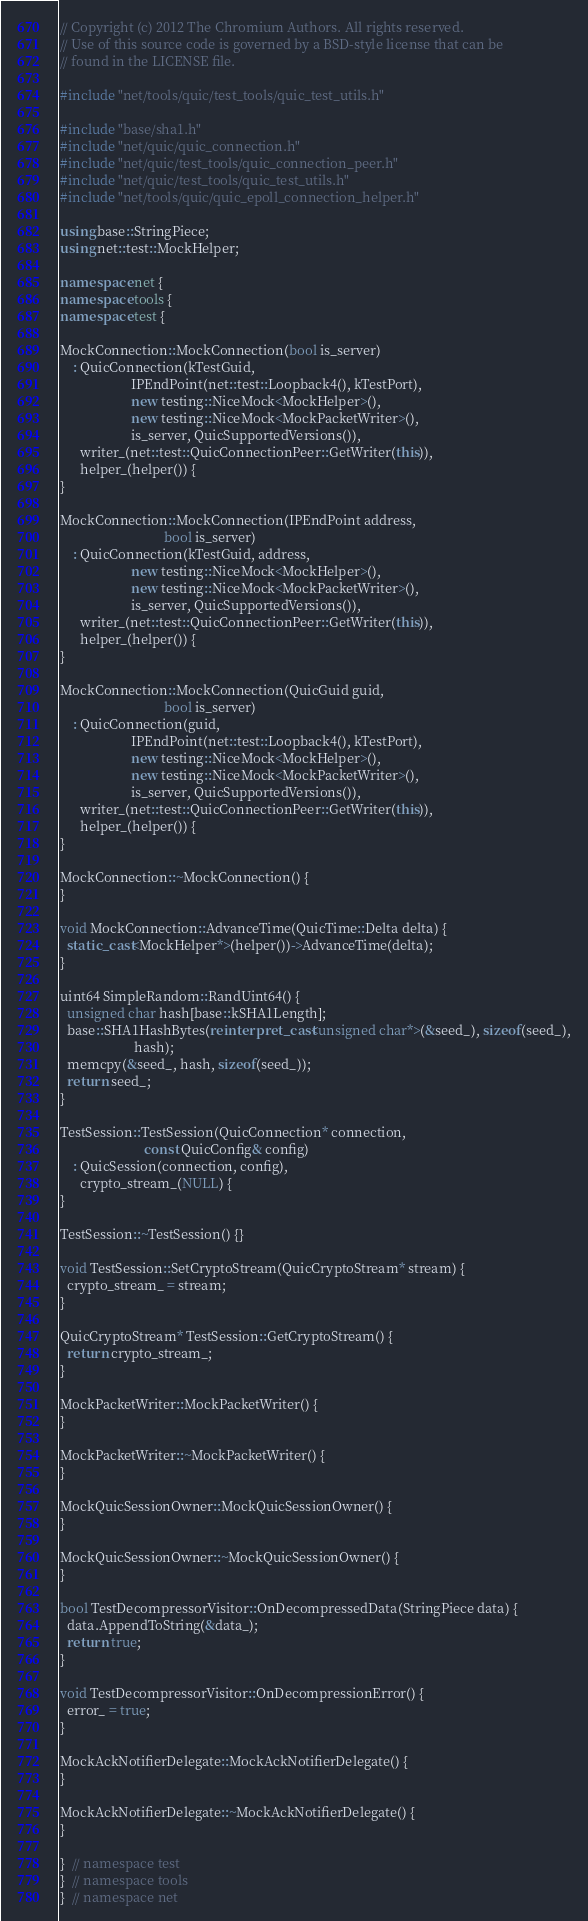<code> <loc_0><loc_0><loc_500><loc_500><_C++_>// Copyright (c) 2012 The Chromium Authors. All rights reserved.
// Use of this source code is governed by a BSD-style license that can be
// found in the LICENSE file.

#include "net/tools/quic/test_tools/quic_test_utils.h"

#include "base/sha1.h"
#include "net/quic/quic_connection.h"
#include "net/quic/test_tools/quic_connection_peer.h"
#include "net/quic/test_tools/quic_test_utils.h"
#include "net/tools/quic/quic_epoll_connection_helper.h"

using base::StringPiece;
using net::test::MockHelper;

namespace net {
namespace tools {
namespace test {

MockConnection::MockConnection(bool is_server)
    : QuicConnection(kTestGuid,
                     IPEndPoint(net::test::Loopback4(), kTestPort),
                     new testing::NiceMock<MockHelper>(),
                     new testing::NiceMock<MockPacketWriter>(),
                     is_server, QuicSupportedVersions()),
      writer_(net::test::QuicConnectionPeer::GetWriter(this)),
      helper_(helper()) {
}

MockConnection::MockConnection(IPEndPoint address,
                               bool is_server)
    : QuicConnection(kTestGuid, address,
                     new testing::NiceMock<MockHelper>(),
                     new testing::NiceMock<MockPacketWriter>(),
                     is_server, QuicSupportedVersions()),
      writer_(net::test::QuicConnectionPeer::GetWriter(this)),
      helper_(helper()) {
}

MockConnection::MockConnection(QuicGuid guid,
                               bool is_server)
    : QuicConnection(guid,
                     IPEndPoint(net::test::Loopback4(), kTestPort),
                     new testing::NiceMock<MockHelper>(),
                     new testing::NiceMock<MockPacketWriter>(),
                     is_server, QuicSupportedVersions()),
      writer_(net::test::QuicConnectionPeer::GetWriter(this)),
      helper_(helper()) {
}

MockConnection::~MockConnection() {
}

void MockConnection::AdvanceTime(QuicTime::Delta delta) {
  static_cast<MockHelper*>(helper())->AdvanceTime(delta);
}

uint64 SimpleRandom::RandUint64() {
  unsigned char hash[base::kSHA1Length];
  base::SHA1HashBytes(reinterpret_cast<unsigned char*>(&seed_), sizeof(seed_),
                      hash);
  memcpy(&seed_, hash, sizeof(seed_));
  return seed_;
}

TestSession::TestSession(QuicConnection* connection,
                         const QuicConfig& config)
    : QuicSession(connection, config),
      crypto_stream_(NULL) {
}

TestSession::~TestSession() {}

void TestSession::SetCryptoStream(QuicCryptoStream* stream) {
  crypto_stream_ = stream;
}

QuicCryptoStream* TestSession::GetCryptoStream() {
  return crypto_stream_;
}

MockPacketWriter::MockPacketWriter() {
}

MockPacketWriter::~MockPacketWriter() {
}

MockQuicSessionOwner::MockQuicSessionOwner() {
}

MockQuicSessionOwner::~MockQuicSessionOwner() {
}

bool TestDecompressorVisitor::OnDecompressedData(StringPiece data) {
  data.AppendToString(&data_);
  return true;
}

void TestDecompressorVisitor::OnDecompressionError() {
  error_ = true;
}

MockAckNotifierDelegate::MockAckNotifierDelegate() {
}

MockAckNotifierDelegate::~MockAckNotifierDelegate() {
}

}  // namespace test
}  // namespace tools
}  // namespace net
</code> 